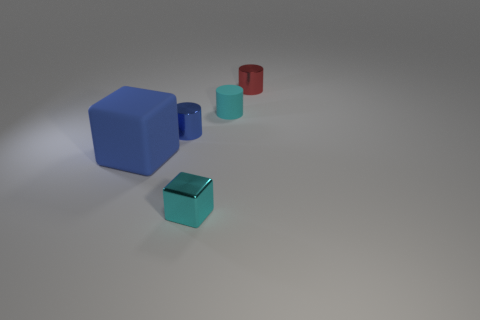Subtract all red metal cylinders. How many cylinders are left? 2 Add 3 tiny blue objects. How many objects exist? 8 Subtract all cylinders. How many objects are left? 2 Subtract all brown blocks. Subtract all cyan balls. How many blocks are left? 2 Add 3 red things. How many red things are left? 4 Add 1 small blue shiny things. How many small blue shiny things exist? 2 Subtract 0 green cubes. How many objects are left? 5 Subtract all red spheres. Subtract all cyan rubber things. How many objects are left? 4 